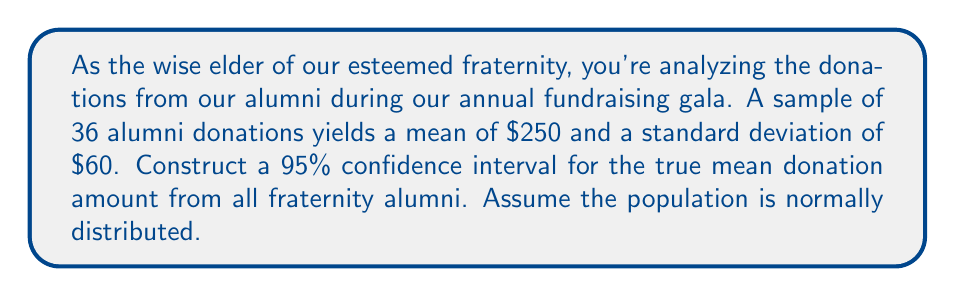Show me your answer to this math problem. Let's approach this step-by-step:

1) We're dealing with a confidence interval for a population mean with unknown population standard deviation. We'll use the t-distribution.

2) Given information:
   - Sample size: $n = 36$
   - Sample mean: $\bar{x} = \$250$
   - Sample standard deviation: $s = \$60$
   - Confidence level: 95%

3) The formula for the confidence interval is:

   $$\bar{x} \pm t_{\alpha/2} \cdot \frac{s}{\sqrt{n}}$$

4) We need to find $t_{\alpha/2}$ for a 95% confidence level with 35 degrees of freedom (df = n - 1 = 35).
   From t-distribution table, $t_{0.025, 35} \approx 2.030$

5) Now, let's calculate the margin of error:

   $$\text{Margin of Error} = t_{\alpha/2} \cdot \frac{s}{\sqrt{n}} = 2.030 \cdot \frac{60}{\sqrt{36}} = 2.030 \cdot 10 = 20.30$$

6) Therefore, the confidence interval is:

   $$250 \pm 20.30$$

7) This gives us the interval:

   $$(\$229.70, \$270.30)$$
Answer: ($229.70, $270.30) 